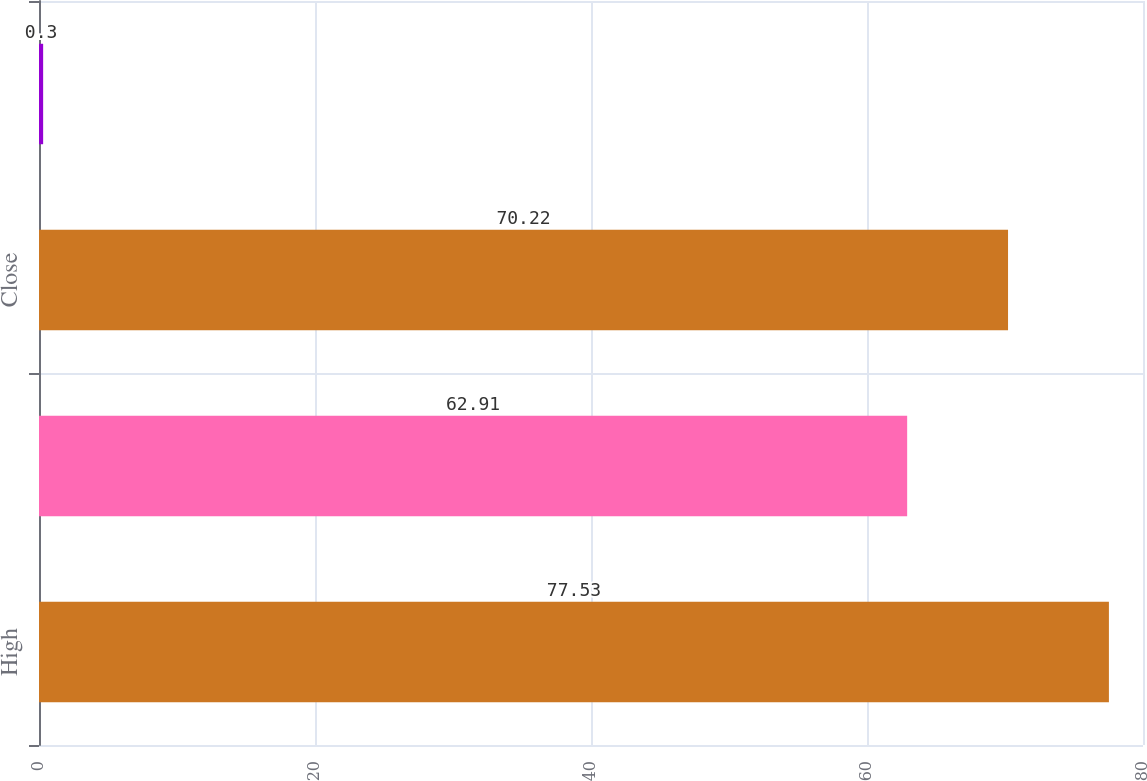<chart> <loc_0><loc_0><loc_500><loc_500><bar_chart><fcel>High<fcel>Low<fcel>Close<fcel>Dividends paid<nl><fcel>77.53<fcel>62.91<fcel>70.22<fcel>0.3<nl></chart> 